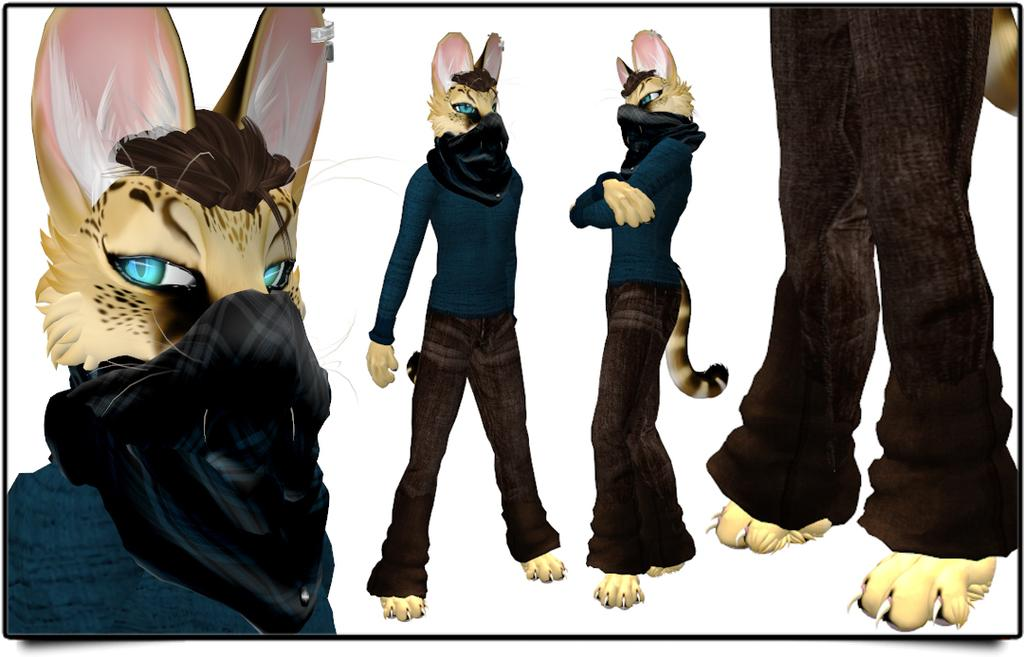What types of living organisms are present in the image? There are animals in the image. What distinguishing feature do the animals have? The animals are wearing clothes. What color is the background of the image? The background of the image is white. What type of tent can be seen in the image? There is no tent present in the image. What can be used to write on the animals in the image? There is no pen or writing instrument present in the image. 